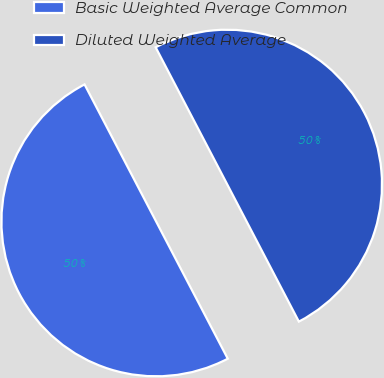<chart> <loc_0><loc_0><loc_500><loc_500><pie_chart><fcel>Basic Weighted Average Common<fcel>Diluted Weighted Average<nl><fcel>50.0%<fcel>50.0%<nl></chart> 